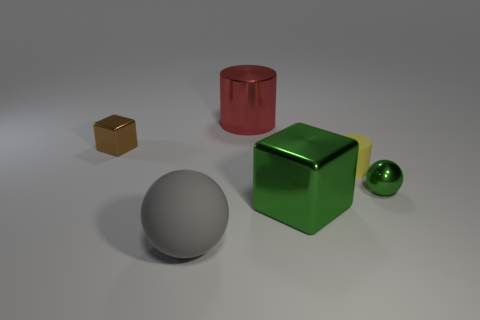How many other objects are there of the same material as the yellow thing?
Keep it short and to the point. 1. There is a small ball that is made of the same material as the tiny cube; what color is it?
Keep it short and to the point. Green. What number of metallic things are either big green cylinders or tiny balls?
Give a very brief answer. 1. Do the big red cylinder and the tiny brown object have the same material?
Provide a succinct answer. Yes. There is a rubber thing that is behind the big green object; what shape is it?
Provide a short and direct response. Cylinder. Are there any small yellow matte cylinders that are in front of the sphere to the left of the yellow matte thing?
Ensure brevity in your answer.  No. Is there a metallic block that has the same size as the gray thing?
Your answer should be compact. Yes. Is the color of the small metal thing that is right of the rubber cylinder the same as the matte ball?
Your answer should be very brief. No. What is the size of the gray thing?
Provide a succinct answer. Large. There is a metallic object in front of the sphere that is behind the big gray rubber thing; what size is it?
Make the answer very short. Large. 